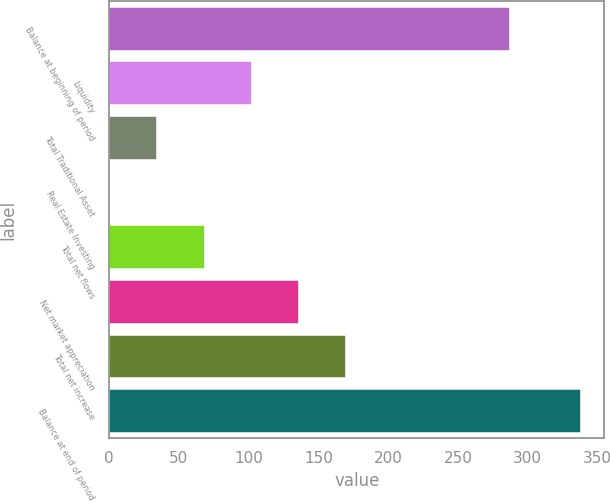Convert chart to OTSL. <chart><loc_0><loc_0><loc_500><loc_500><bar_chart><fcel>Balance at beginning of period<fcel>Liquidity<fcel>Total Traditional Asset<fcel>Real Estate Investing<fcel>Total net flows<fcel>Net market appreciation<fcel>Total net increase<fcel>Balance at end of period<nl><fcel>287<fcel>102.1<fcel>34.7<fcel>1<fcel>68.4<fcel>135.8<fcel>169.5<fcel>338<nl></chart> 